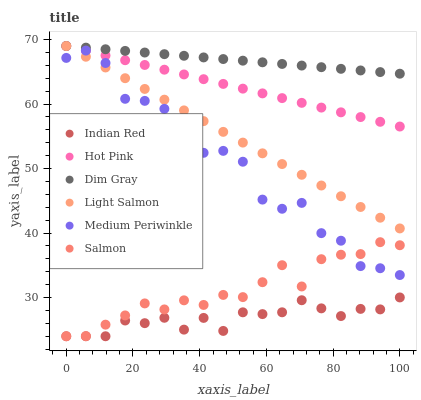Does Indian Red have the minimum area under the curve?
Answer yes or no. Yes. Does Dim Gray have the maximum area under the curve?
Answer yes or no. Yes. Does Medium Periwinkle have the minimum area under the curve?
Answer yes or no. No. Does Medium Periwinkle have the maximum area under the curve?
Answer yes or no. No. Is Hot Pink the smoothest?
Answer yes or no. Yes. Is Medium Periwinkle the roughest?
Answer yes or no. Yes. Is Dim Gray the smoothest?
Answer yes or no. No. Is Dim Gray the roughest?
Answer yes or no. No. Does Salmon have the lowest value?
Answer yes or no. Yes. Does Medium Periwinkle have the lowest value?
Answer yes or no. No. Does Hot Pink have the highest value?
Answer yes or no. Yes. Does Medium Periwinkle have the highest value?
Answer yes or no. No. Is Salmon less than Hot Pink?
Answer yes or no. Yes. Is Dim Gray greater than Indian Red?
Answer yes or no. Yes. Does Light Salmon intersect Dim Gray?
Answer yes or no. Yes. Is Light Salmon less than Dim Gray?
Answer yes or no. No. Is Light Salmon greater than Dim Gray?
Answer yes or no. No. Does Salmon intersect Hot Pink?
Answer yes or no. No. 